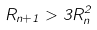Convert formula to latex. <formula><loc_0><loc_0><loc_500><loc_500>R _ { n + 1 } > 3 R _ { n } ^ { 2 }</formula> 